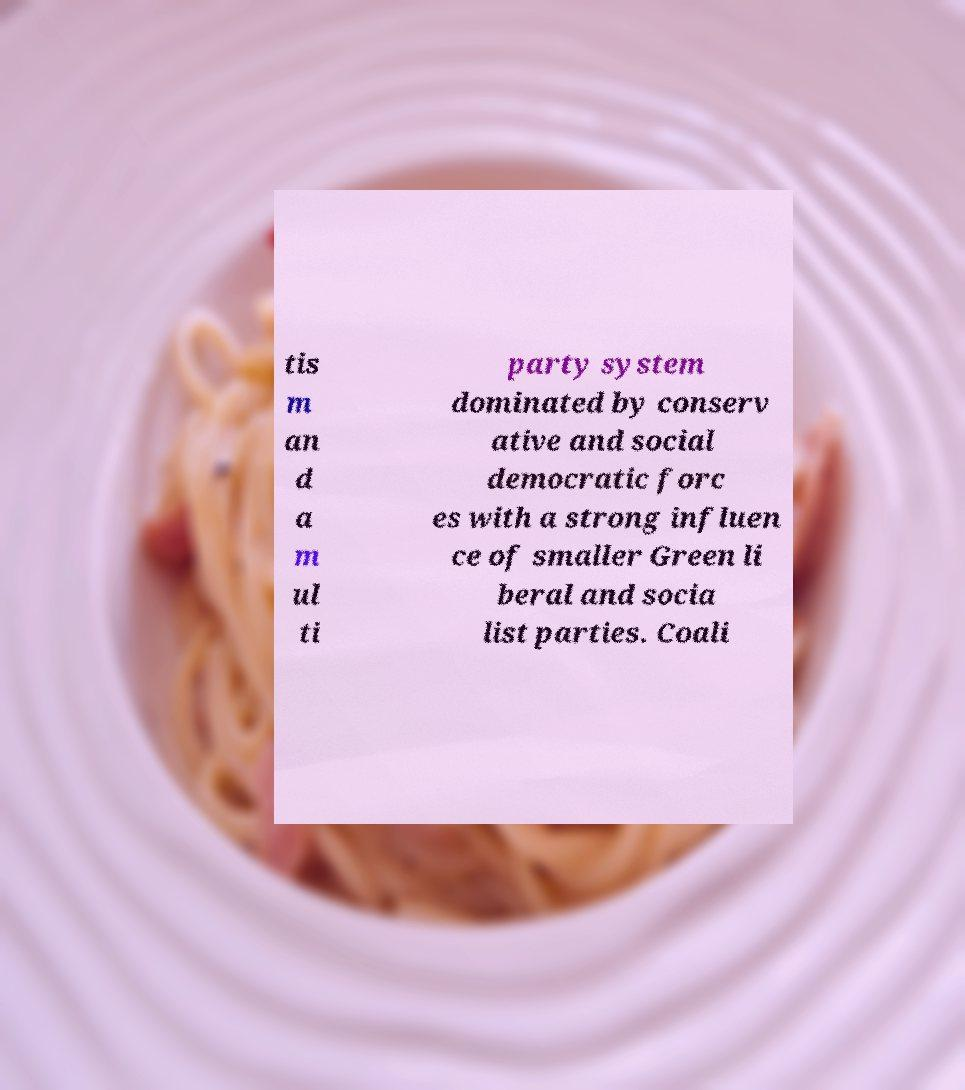What messages or text are displayed in this image? I need them in a readable, typed format. tis m an d a m ul ti party system dominated by conserv ative and social democratic forc es with a strong influen ce of smaller Green li beral and socia list parties. Coali 